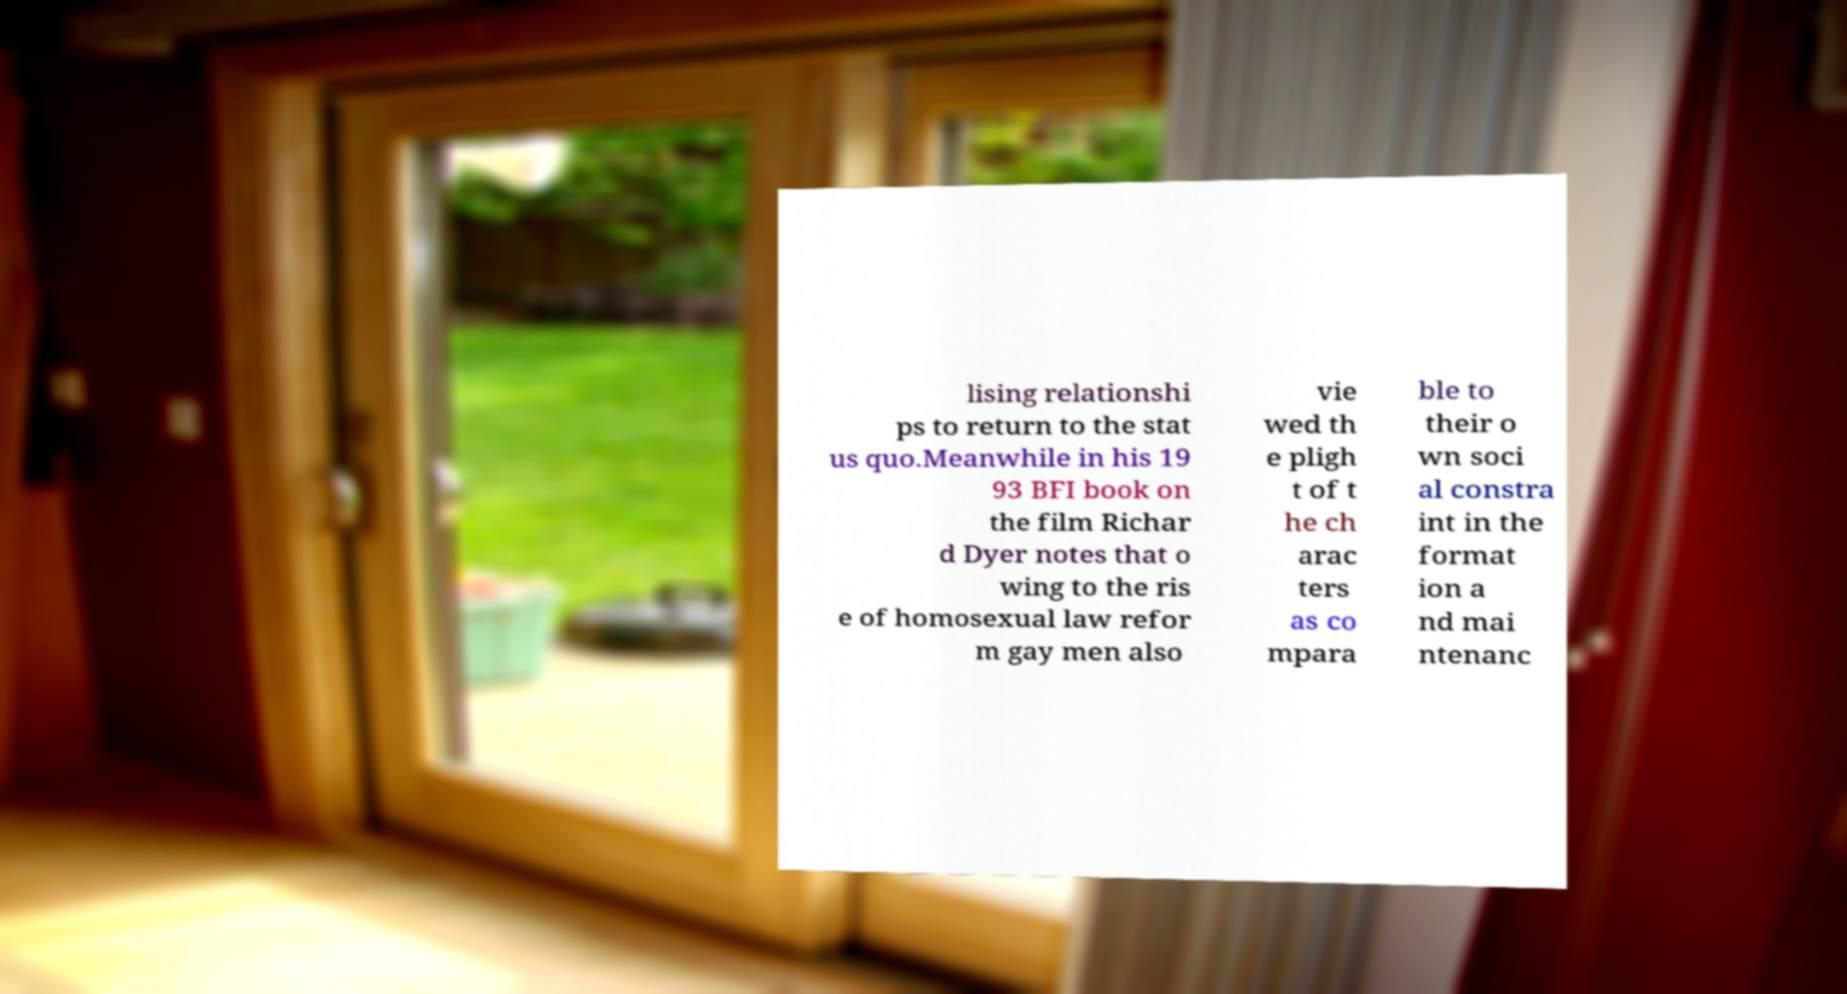Please read and relay the text visible in this image. What does it say? lising relationshi ps to return to the stat us quo.Meanwhile in his 19 93 BFI book on the film Richar d Dyer notes that o wing to the ris e of homosexual law refor m gay men also vie wed th e pligh t of t he ch arac ters as co mpara ble to their o wn soci al constra int in the format ion a nd mai ntenanc 